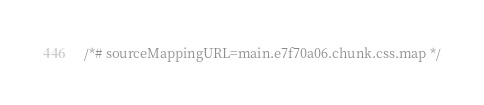Convert code to text. <code><loc_0><loc_0><loc_500><loc_500><_CSS_>/*# sourceMappingURL=main.e7f70a06.chunk.css.map */</code> 